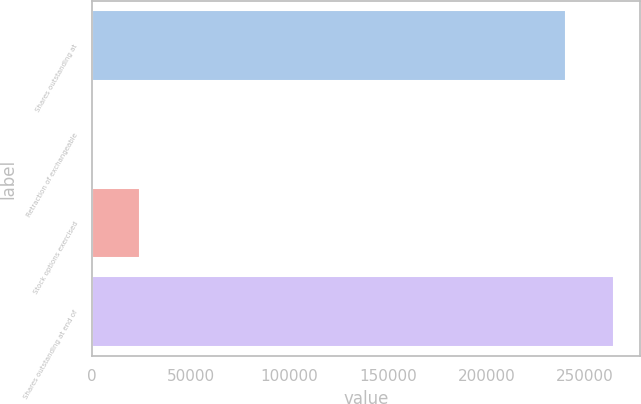Convert chart to OTSL. <chart><loc_0><loc_0><loc_500><loc_500><bar_chart><fcel>Shares outstanding at<fcel>Retraction of exchangeable<fcel>Stock options exercised<fcel>Shares outstanding at end of<nl><fcel>240361<fcel>66<fcel>24373.2<fcel>264668<nl></chart> 